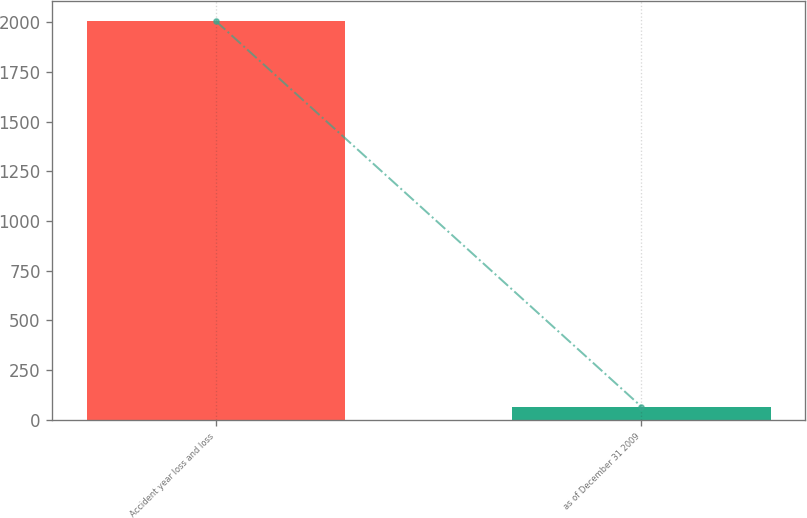Convert chart. <chart><loc_0><loc_0><loc_500><loc_500><bar_chart><fcel>Accident year loss and loss<fcel>as of December 31 2009<nl><fcel>2007<fcel>66.7<nl></chart> 